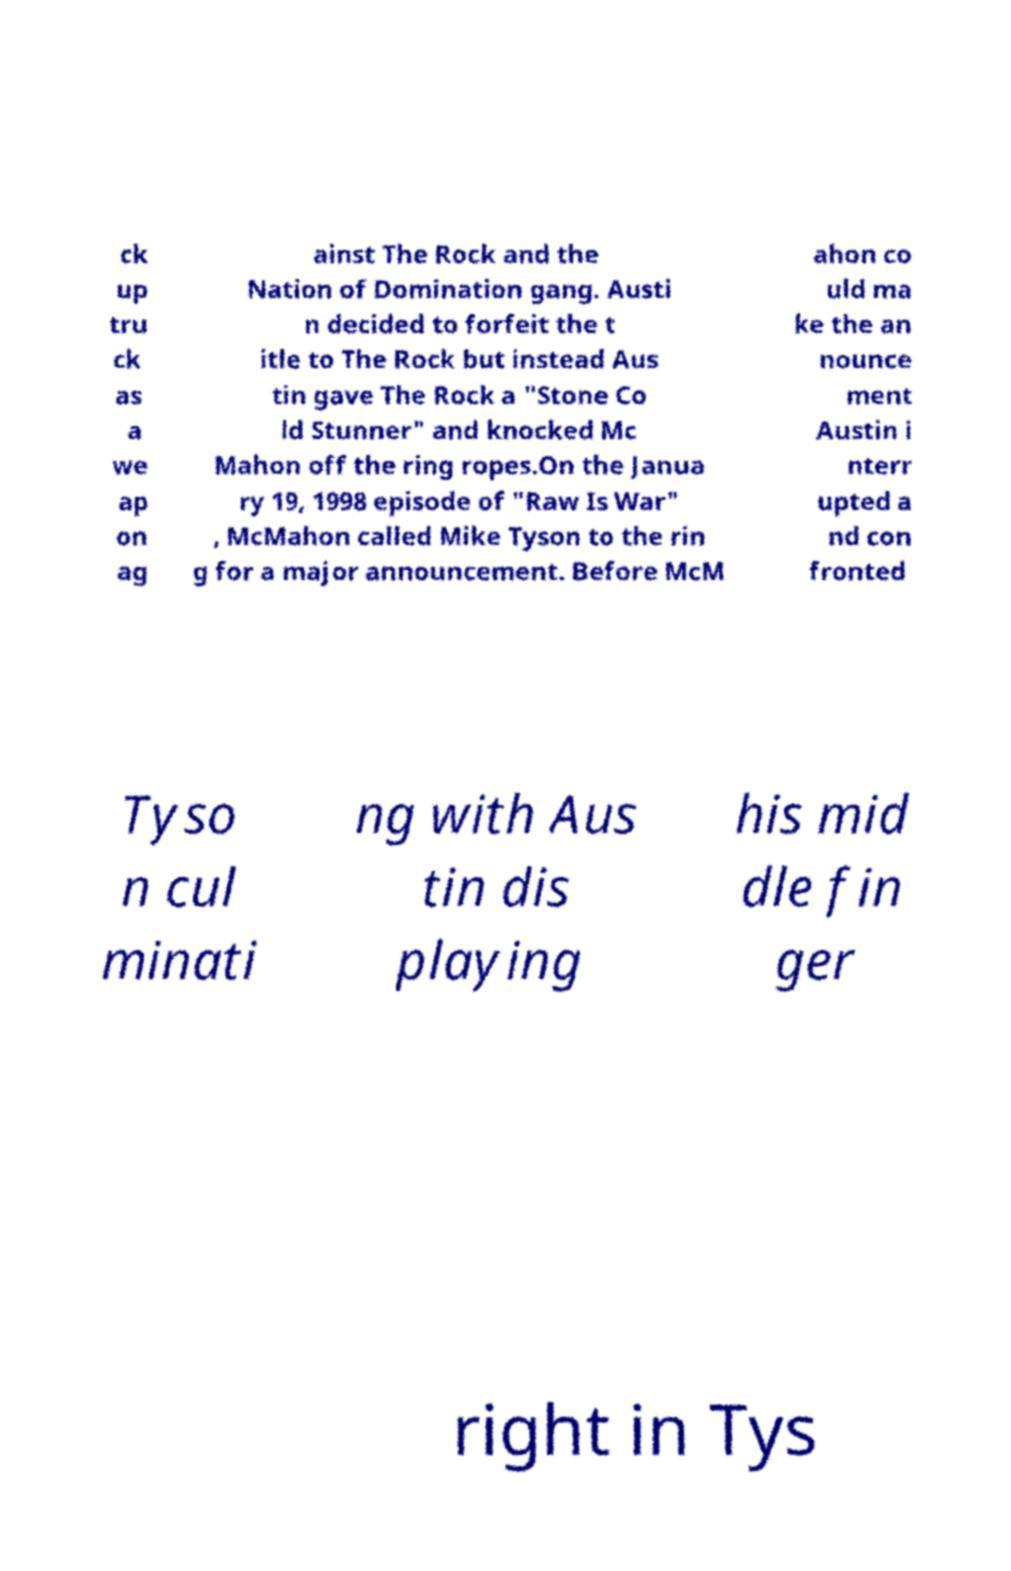Can you accurately transcribe the text from the provided image for me? ck up tru ck as a we ap on ag ainst The Rock and the Nation of Domination gang. Austi n decided to forfeit the t itle to The Rock but instead Aus tin gave The Rock a "Stone Co ld Stunner" and knocked Mc Mahon off the ring ropes.On the Janua ry 19, 1998 episode of "Raw Is War" , McMahon called Mike Tyson to the rin g for a major announcement. Before McM ahon co uld ma ke the an nounce ment Austin i nterr upted a nd con fronted Tyso n cul minati ng with Aus tin dis playing his mid dle fin ger right in Tys 